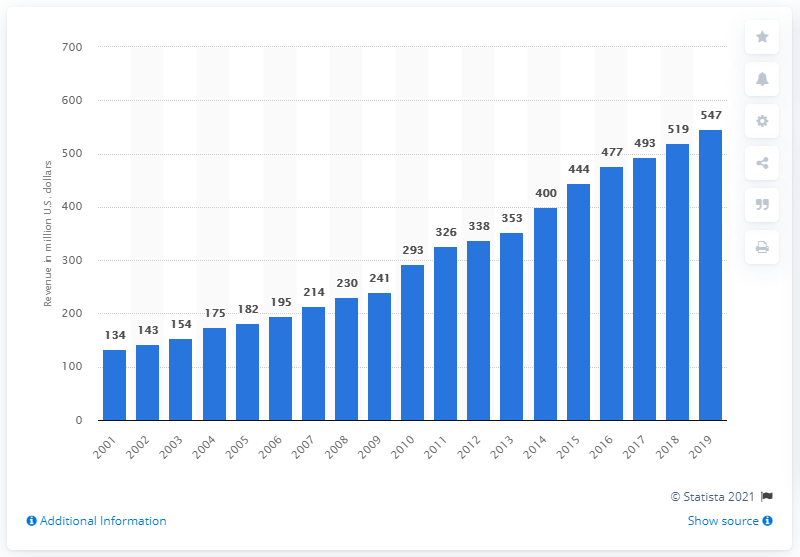Specify some key components in this picture. The revenue of the New York Giants in 2019 was $547 million. 